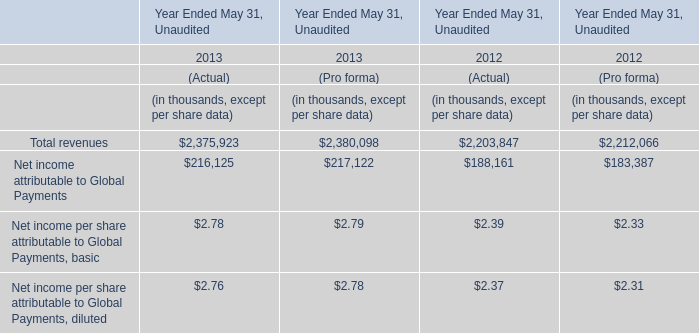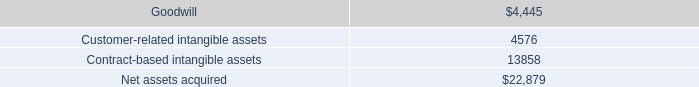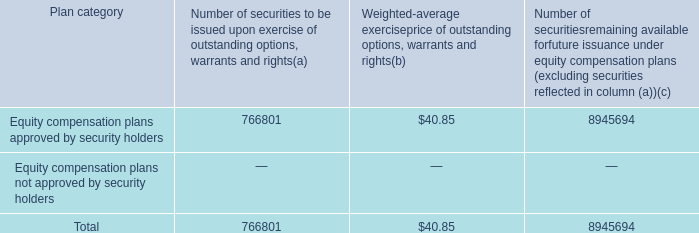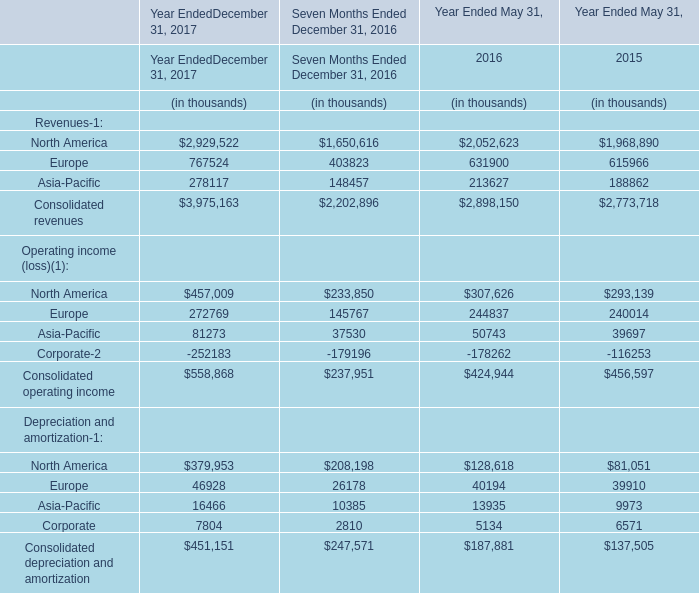What's the growth rate of Consolidated operating income in 2016? 
Computations: ((424944 - 456597) / 456597)
Answer: -0.06932. 